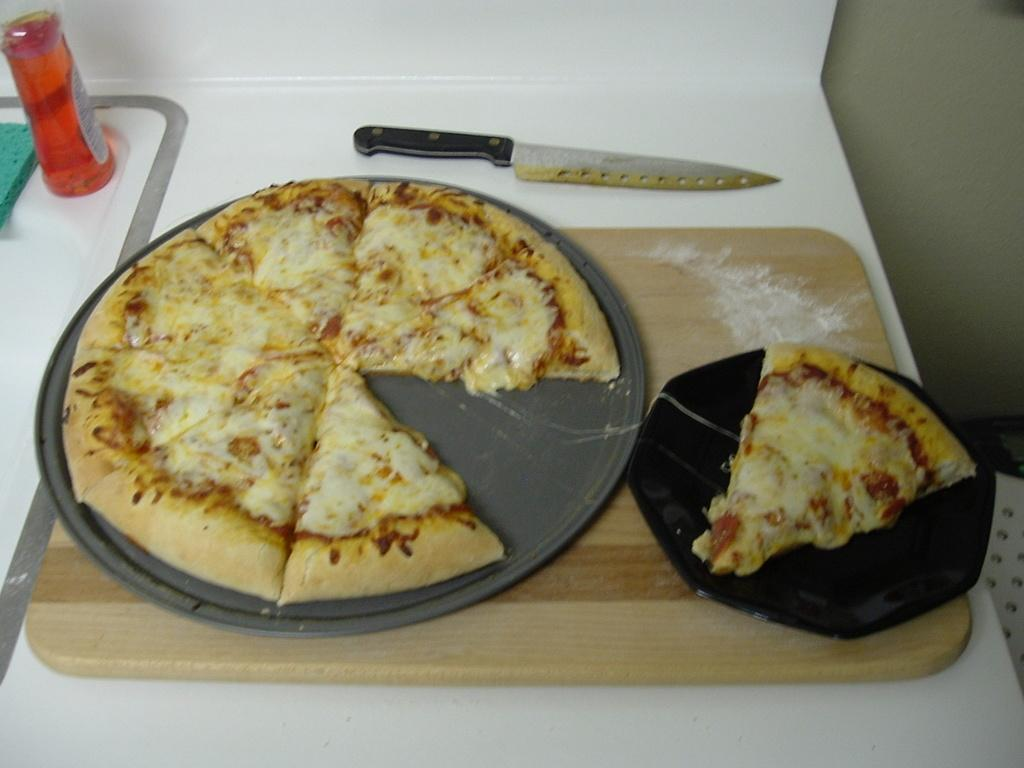What is the main subject in the center of the image? There is food in the center of the image. What utensil is present in the image? There is a knife in the image. What can be seen on the left side of the image? There is a bottle on the left side of the image. Can you describe the color of any object in the image? There is an object that is green in color. What type of material is used for a specific object in the image? There is a wooden plank in the image. How does the bat contribute to the payment process in the image? There is no bat or payment process present in the image. 